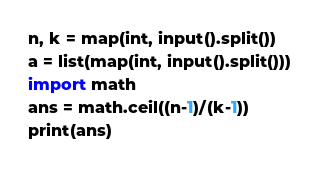Convert code to text. <code><loc_0><loc_0><loc_500><loc_500><_Python_>n, k = map(int, input().split())
a = list(map(int, input().split()))
import math
ans = math.ceil((n-1)/(k-1))
print(ans)</code> 